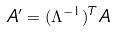<formula> <loc_0><loc_0><loc_500><loc_500>A ^ { \prime } = ( \Lambda ^ { - 1 } ) ^ { T } A</formula> 